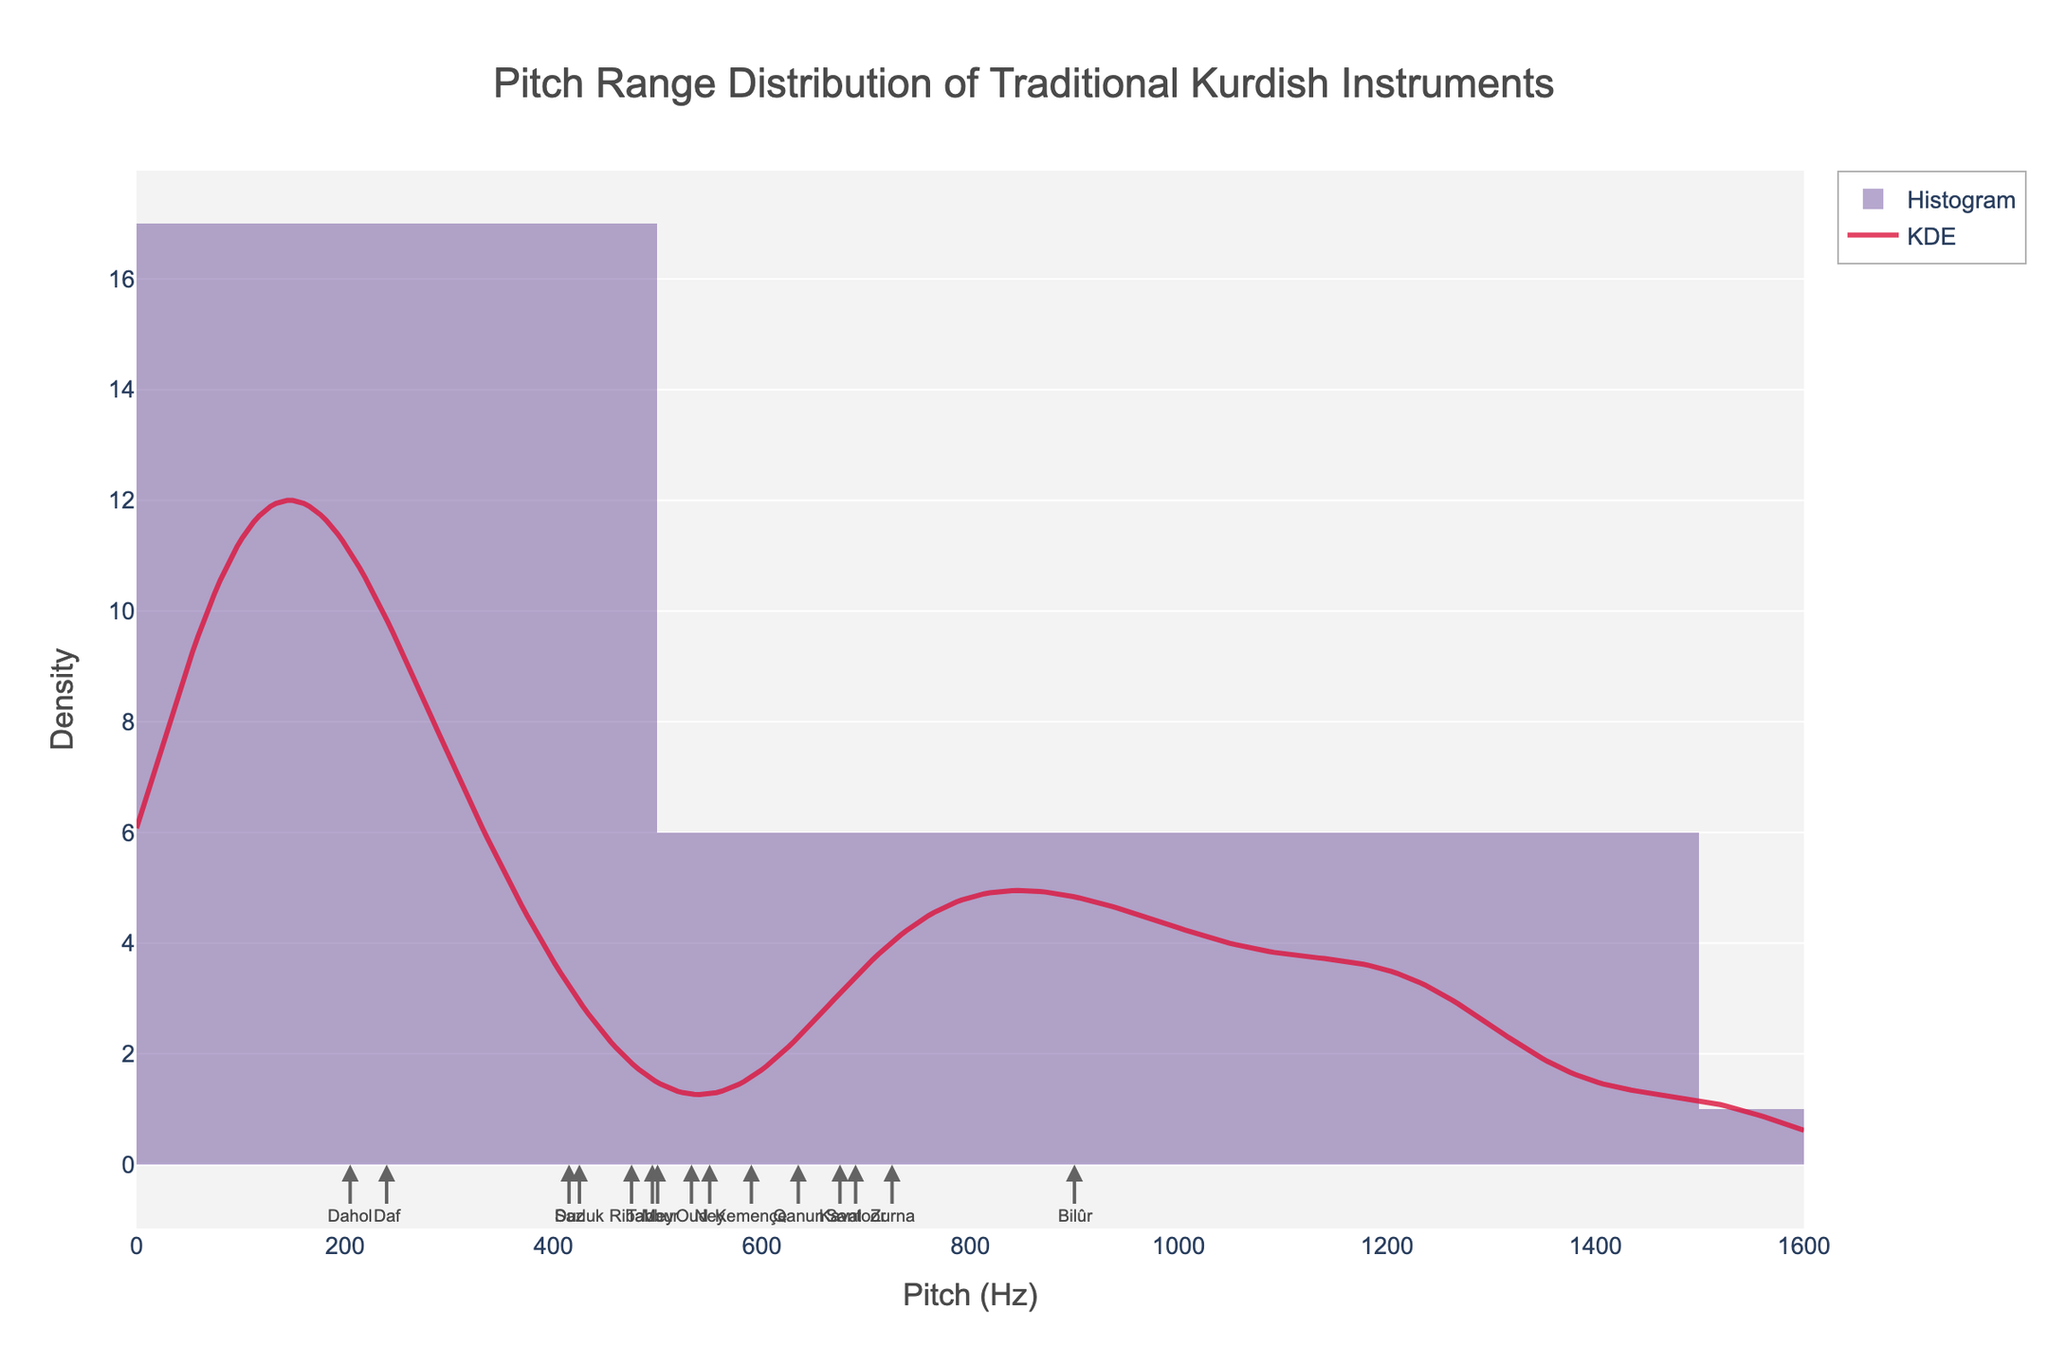What is the title of the plot? The title is usually displayed at the top of the figure. In this case, it is centered and text-styled for clear visibility.
Answer: Pitch Range Distribution of Traditional Kurdish Instruments What is the x-axis labeled? The x-axis label can be found towards the bottom of the x-axis, clearly stating what is being measured.
Answer: Pitch (Hz) How many instruments have a maximum pitch range above 1000 Hz? Look at the histogram and identify the bars corresponding to pitch ranges above 1000 Hz. Also, use KDE curve as reference if needed. Count the strings falling under this region.
Answer: 4 Which instrument has the widest pitch range? By comparing the range (difference between maximum and minimum value) for each instrument. The KDE peaks and histogram bars help visual confirmation.
Answer: Santoor Which pitch range appears most frequently? Identify the tallest bars in the histogram and the peak(s) of the KDE curve, which indicate the most common pitch range.
Answer: 200-400 Hz What is the pitch range of the Tanbur? Based on the annotations for each instrument in the plot, find the label for Tanbur and note its position along the x-axis.
Answer: 110-880 Hz What is the average of the minimum pitch values? Calculate the sum of all minimum pitch values of the instruments and divide by the number of instruments. This requires adding individual minimum pitch values and dividing the result by the number of instruments (15).
Answer: 159.33 Hz How does the pitch range of Ney compare to Kemençe? Identify the pitch ranges of each instrument using their annotations and compare their minimum and maximum values.
Answer: Ney: 200-900 Hz, Kemençe: 180-1000 Hz Between which two instruments would a shift in pitch range likely lead to the most noticeable change in sonic character? Compare the pitch ranges of all instruments and find the two with the largest difference in both minimum and maximum values, indicating a significant contrast in their pitch ranges.
Answer: Dahol and Santoor 